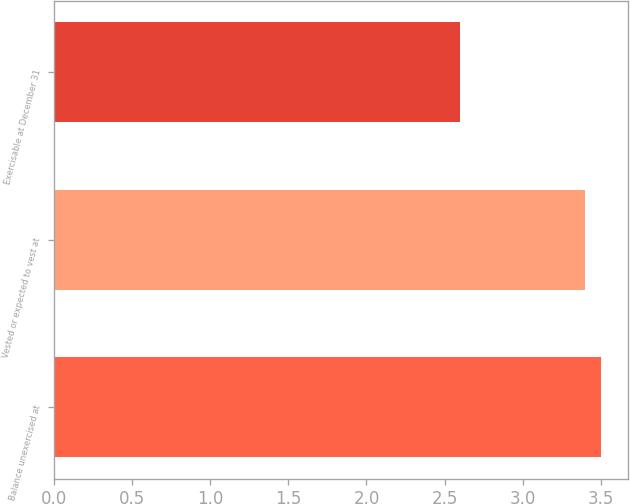Convert chart. <chart><loc_0><loc_0><loc_500><loc_500><bar_chart><fcel>Balance unexercised at<fcel>Vested or expected to vest at<fcel>Exercisable at December 31<nl><fcel>3.5<fcel>3.4<fcel>2.6<nl></chart> 